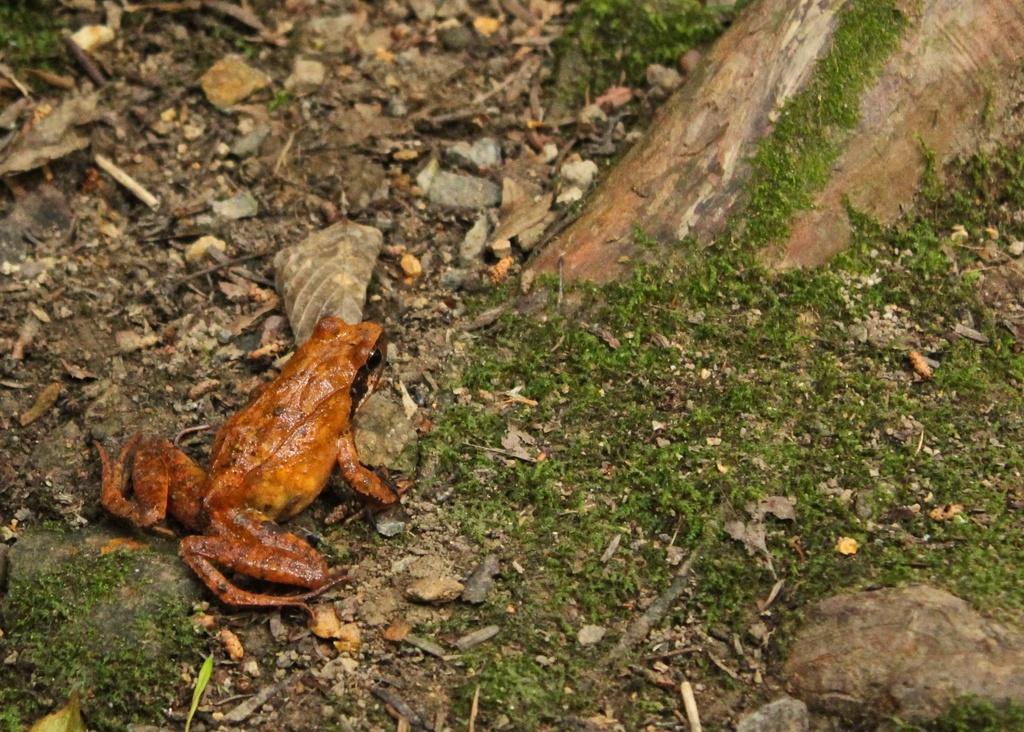Please provide a concise description of this image. In this image there is a frog on the surface, beside the frog there are stones and dry leaves, in front of the frog there is the root of a tree. 